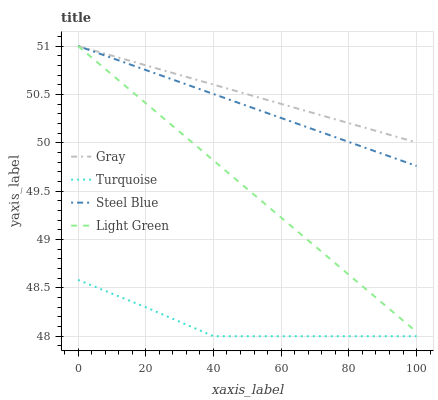Does Turquoise have the minimum area under the curve?
Answer yes or no. Yes. Does Gray have the maximum area under the curve?
Answer yes or no. Yes. Does Steel Blue have the minimum area under the curve?
Answer yes or no. No. Does Steel Blue have the maximum area under the curve?
Answer yes or no. No. Is Light Green the smoothest?
Answer yes or no. Yes. Is Turquoise the roughest?
Answer yes or no. Yes. Is Steel Blue the smoothest?
Answer yes or no. No. Is Steel Blue the roughest?
Answer yes or no. No. Does Turquoise have the lowest value?
Answer yes or no. Yes. Does Steel Blue have the lowest value?
Answer yes or no. No. Does Light Green have the highest value?
Answer yes or no. Yes. Does Turquoise have the highest value?
Answer yes or no. No. Is Turquoise less than Steel Blue?
Answer yes or no. Yes. Is Light Green greater than Turquoise?
Answer yes or no. Yes. Does Steel Blue intersect Gray?
Answer yes or no. Yes. Is Steel Blue less than Gray?
Answer yes or no. No. Is Steel Blue greater than Gray?
Answer yes or no. No. Does Turquoise intersect Steel Blue?
Answer yes or no. No. 